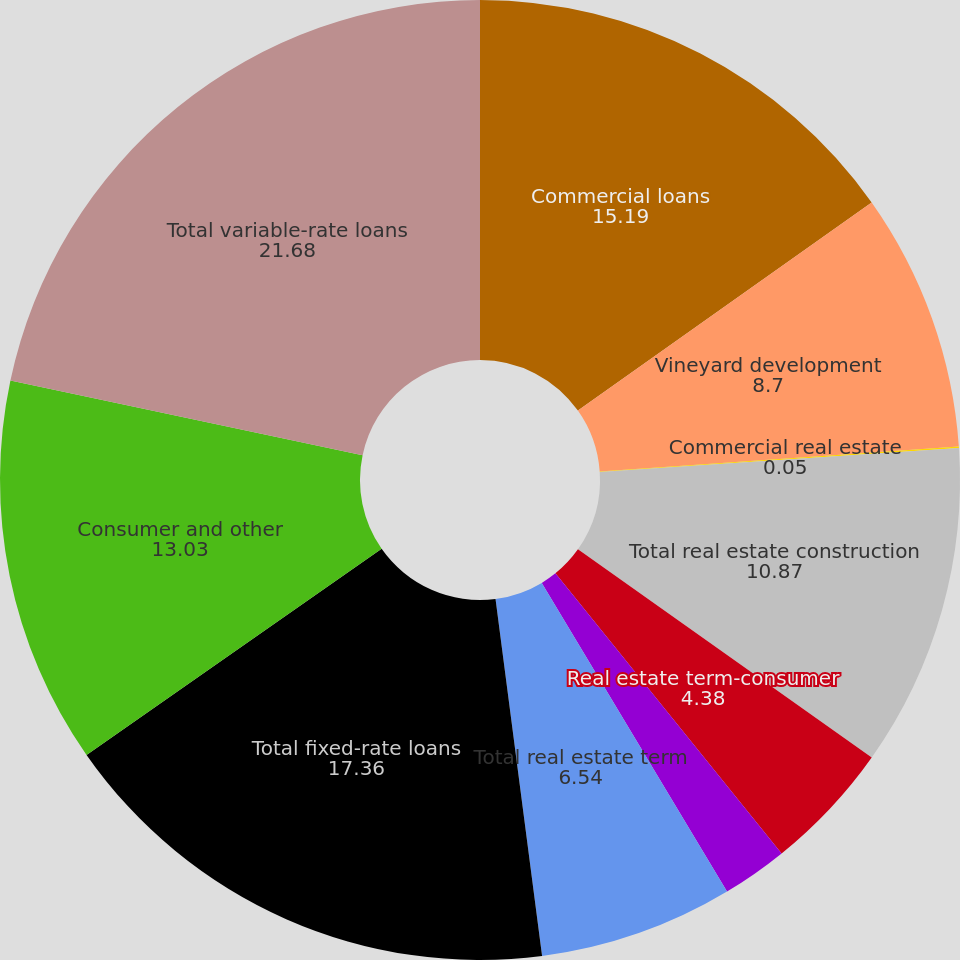<chart> <loc_0><loc_0><loc_500><loc_500><pie_chart><fcel>Commercial loans<fcel>Vineyard development<fcel>Commercial real estate<fcel>Total real estate construction<fcel>Real estate term-consumer<fcel>Real estate term-commercial<fcel>Total real estate term<fcel>Total fixed-rate loans<fcel>Consumer and other<fcel>Total variable-rate loans<nl><fcel>15.19%<fcel>8.7%<fcel>0.05%<fcel>10.87%<fcel>4.38%<fcel>2.21%<fcel>6.54%<fcel>17.36%<fcel>13.03%<fcel>21.68%<nl></chart> 